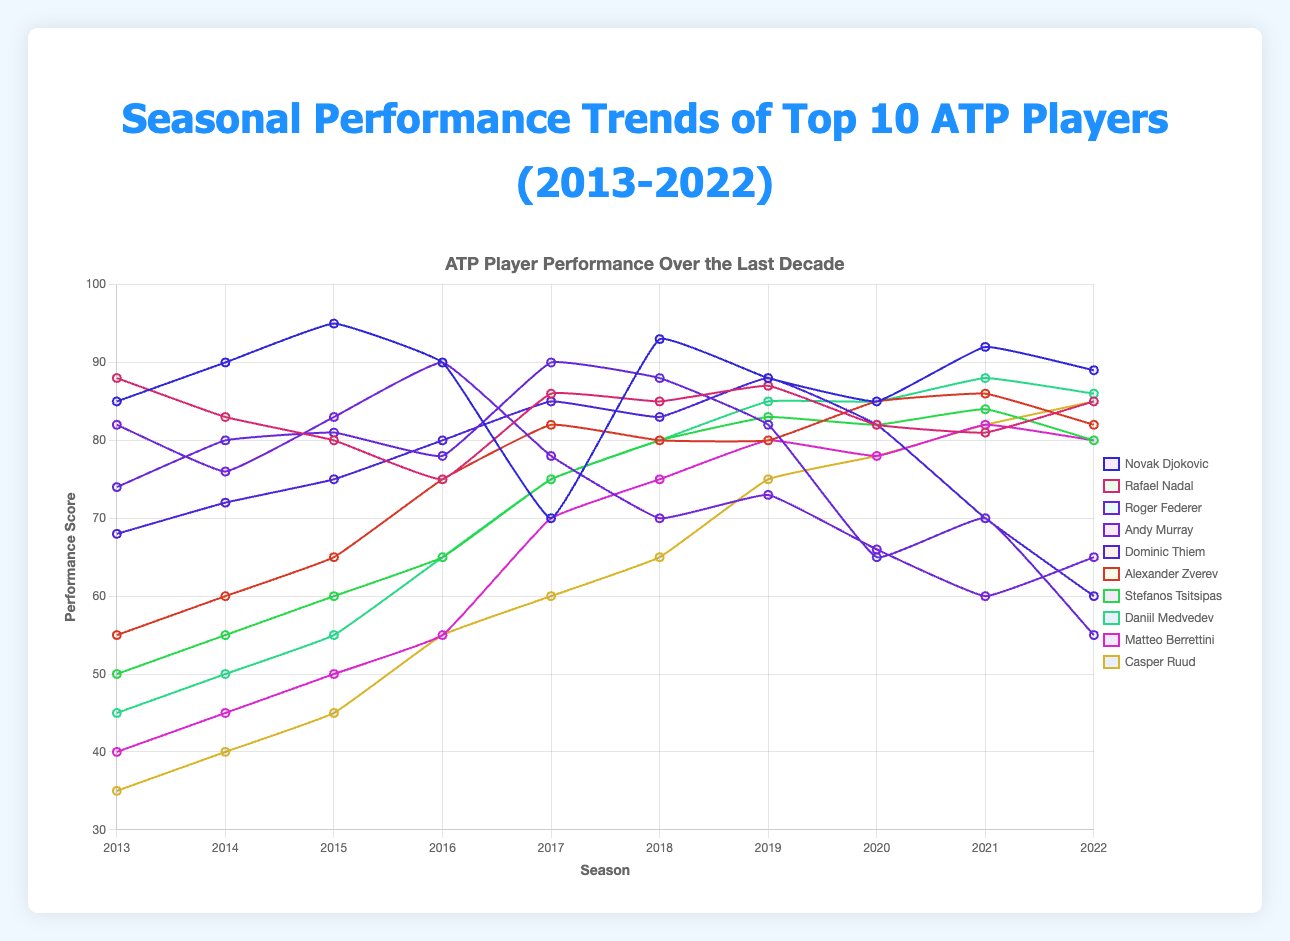What was Novak Djokovic's highest performance score and in which season did it occur? Novak Djokovic's highest performance score is the peak point in his line. His score reached 95 in the 2015 season.
Answer: 95, 2015 How did Roger Federer's performance change between 2019 and 2022? To determine the change, subtract Roger Federer's performance in 2022 from his performance in 2019. The scores are 82 (2019) and 55 (2022). The change is 82 - 55 = 27, indicating a decline.
Answer: Declined by 27 points Which player had the highest average performance over the decade? To find the average, sum up each player's performance scores for every season and divide by 10. Compare each average to determine which player has the highest average.
Answer: Novak Djokovic Between Rafael Nadal and Andy Murray, who had a more consistent performance trend from 2013 to 2022? Check the fluctuations in their performance lines. Rafael Nadal's scores show smaller variations compared to Andy Murray's more erratic trend, indicating more consistency.
Answer: Rafael Nadal Did any player have a performance score below 60 in 2022? Look at the 2022 data points for each player. Roger Federer scored 55, indicating that he had a performance below 60 in 2022.
Answer: Yes, Roger Federer Which player showed the most improvement between the start and end of the decade? Calculate the difference in performance scores between 2022 and 2013 for each player and identify the largest improvement. Casper Ruud's score increased from 35 in 2013 to 85 in 2022, an increase of 50 points.
Answer: Casper Ruud How did Daniil Medvedev's performance change from 2013 to 2014? Compare the data points for 2013 and 2014. His score increased from 45 in 2013 to 50 in 2014, which is an increase of 5 points.
Answer: Increased by 5 points Between 2018 and 2022, which player had the largest drop in performance score? Subtract the 2018 performance score from the 2022 score for each player and identify the largest negative difference. Roger Federer's score dropped from 88 in 2018 to 55 in 2022, a drop of 33 points.
Answer: Roger Federer Which player had the lowest performance score in 2013? Look at the 2013 data points for each player. Casper Ruud had the lowest score at 35.
Answer: Casper Ruud 